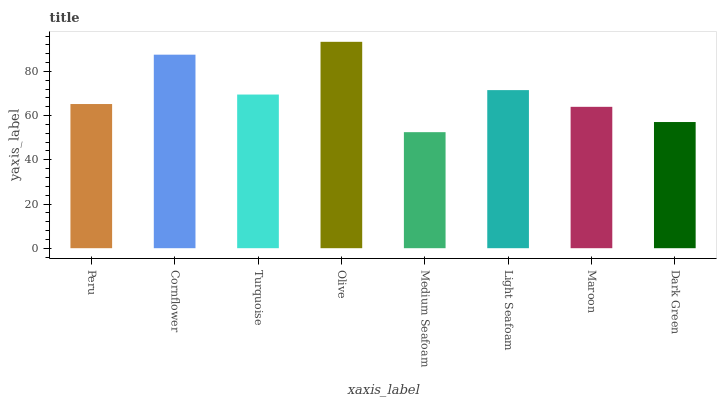Is Medium Seafoam the minimum?
Answer yes or no. Yes. Is Olive the maximum?
Answer yes or no. Yes. Is Cornflower the minimum?
Answer yes or no. No. Is Cornflower the maximum?
Answer yes or no. No. Is Cornflower greater than Peru?
Answer yes or no. Yes. Is Peru less than Cornflower?
Answer yes or no. Yes. Is Peru greater than Cornflower?
Answer yes or no. No. Is Cornflower less than Peru?
Answer yes or no. No. Is Turquoise the high median?
Answer yes or no. Yes. Is Peru the low median?
Answer yes or no. Yes. Is Medium Seafoam the high median?
Answer yes or no. No. Is Maroon the low median?
Answer yes or no. No. 